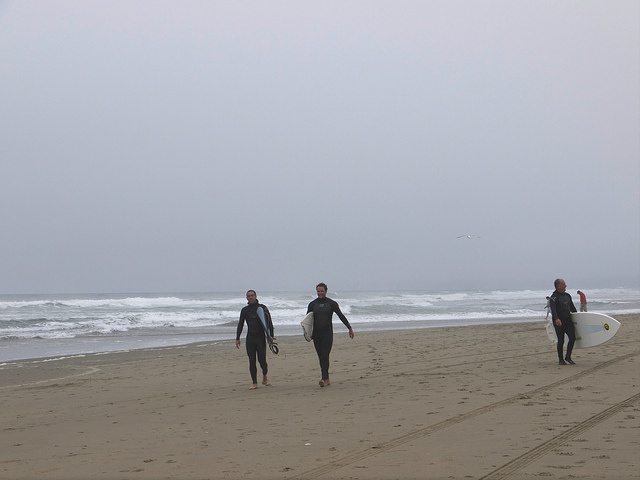Describe the objects in this image and their specific colors. I can see people in lightgray, black, and gray tones, people in lightgray, black, gray, and darkgray tones, surfboard in lightgray and gray tones, people in lightgray, black, gray, and darkgray tones, and surfboard in lightgray, gray, and black tones in this image. 